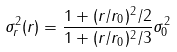<formula> <loc_0><loc_0><loc_500><loc_500>\sigma ^ { 2 } _ { r } ( r ) = \frac { 1 + ( r / r _ { 0 } ) ^ { 2 } / 2 } { 1 + ( r / r _ { 0 } ) ^ { 2 } / 3 } \sigma ^ { 2 } _ { 0 }</formula> 